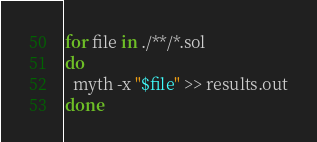<code> <loc_0><loc_0><loc_500><loc_500><_Bash_>for file in ./**/*.sol
do
  myth -x "$file" >> results.out
done

</code> 